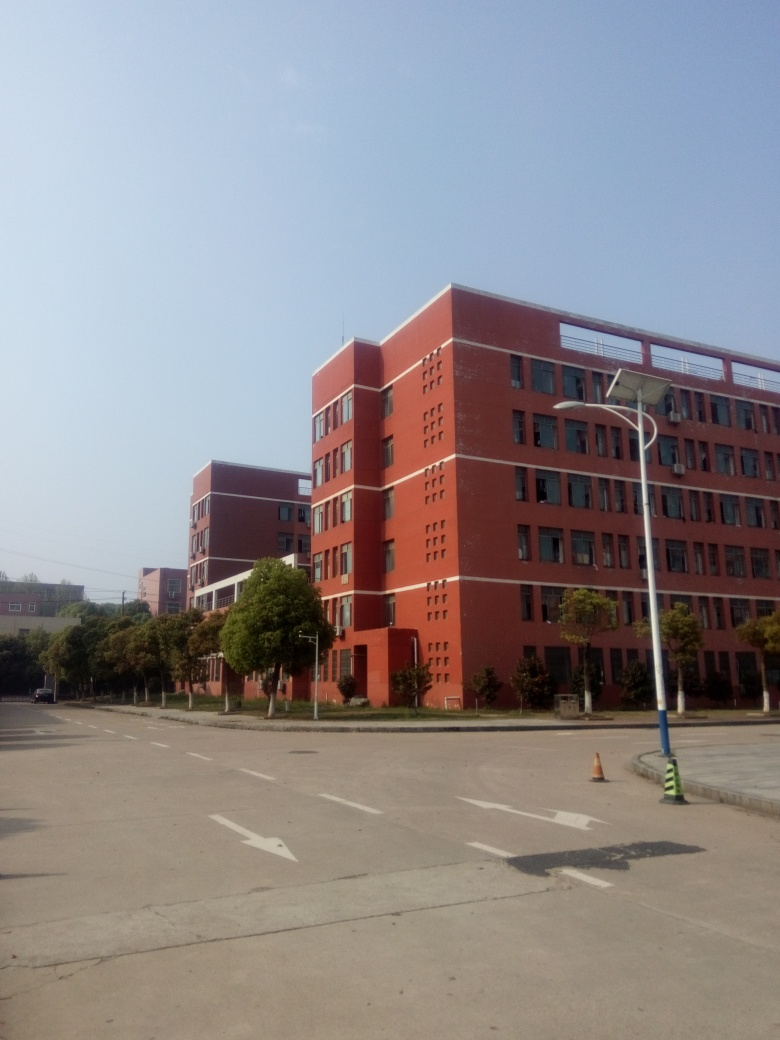Are there any quality issues related to saturation?
A. No
B. Yes
Answer with the option's letter from the given choices directly.
 A. 